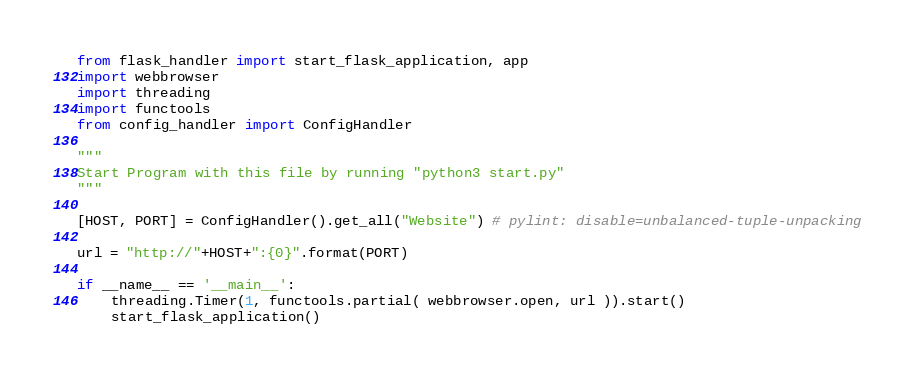Convert code to text. <code><loc_0><loc_0><loc_500><loc_500><_Python_>from flask_handler import start_flask_application, app
import webbrowser
import threading
import functools
from config_handler import ConfigHandler

"""
Start Program with this file by running "python3 start.py"
"""

[HOST, PORT] = ConfigHandler().get_all("Website") # pylint: disable=unbalanced-tuple-unpacking

url = "http://"+HOST+":{0}".format(PORT)

if __name__ == '__main__':
    threading.Timer(1, functools.partial( webbrowser.open, url )).start()
    start_flask_application()
</code> 